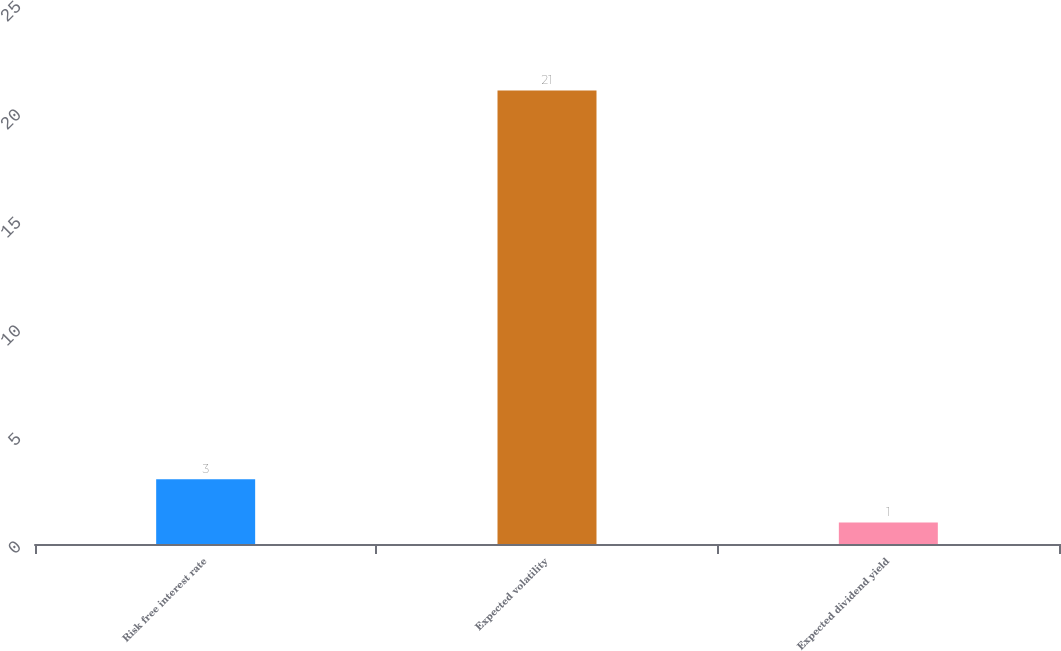Convert chart. <chart><loc_0><loc_0><loc_500><loc_500><bar_chart><fcel>Risk free interest rate<fcel>Expected volatility<fcel>Expected dividend yield<nl><fcel>3<fcel>21<fcel>1<nl></chart> 